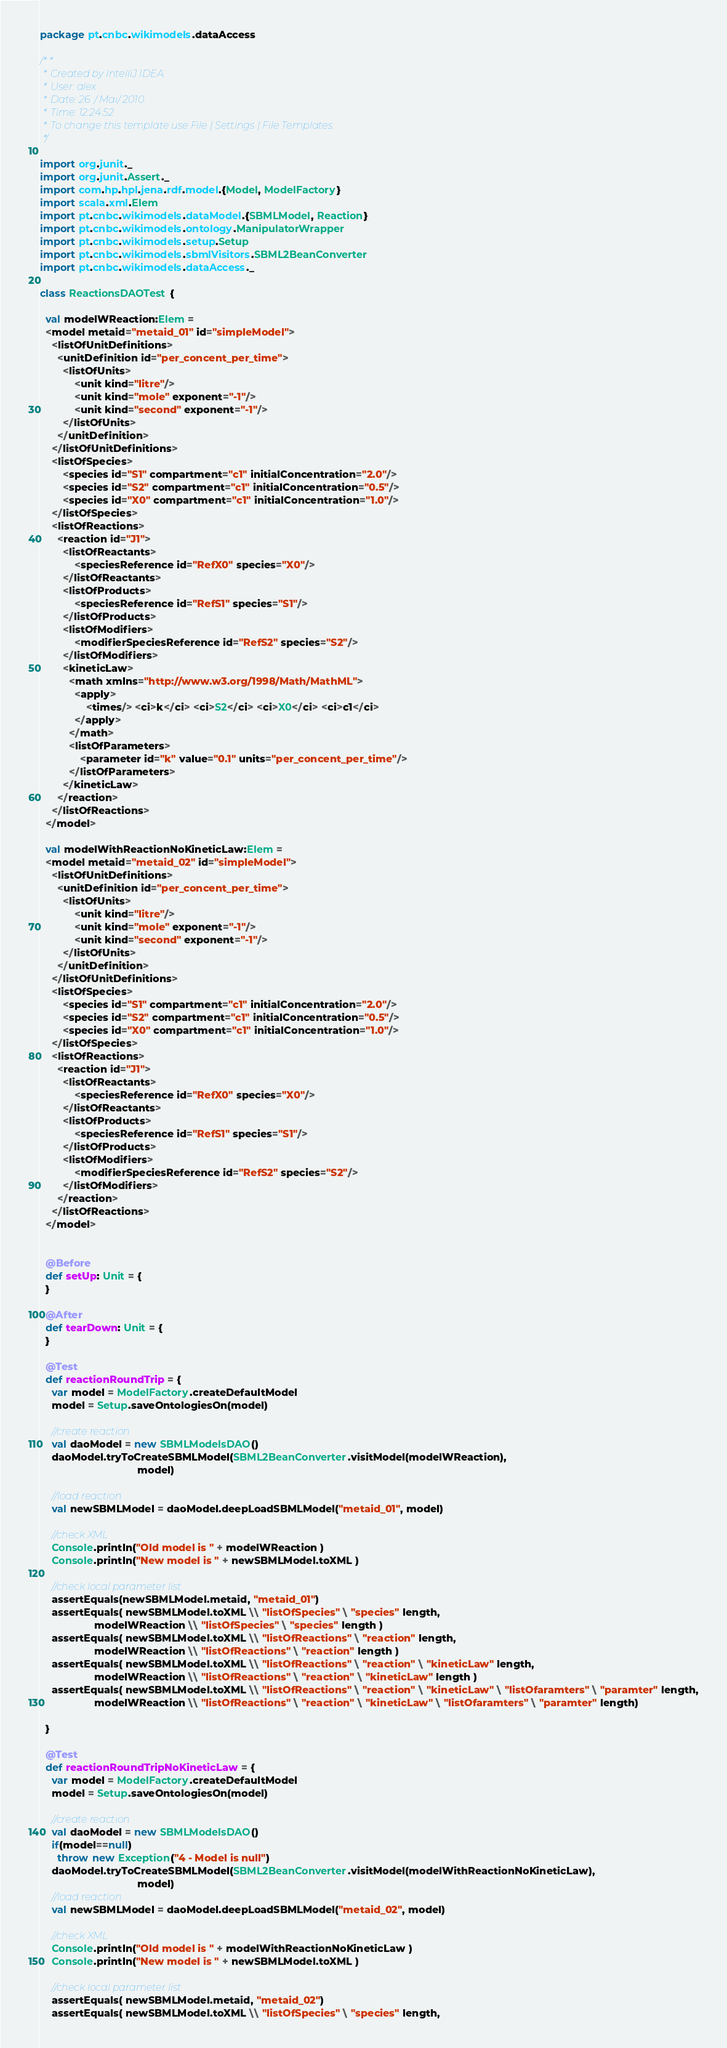Convert code to text. <code><loc_0><loc_0><loc_500><loc_500><_Scala_>package pt.cnbc.wikimodels.dataAccess

/**
 * Created by IntelliJ IDEA.
 * User: alex
 * Date: 26/Mai/2010
 * Time: 12:24:52
 * To change this template use File | Settings | File Templates.
 */

import org.junit._
import org.junit.Assert._
import com.hp.hpl.jena.rdf.model.{Model, ModelFactory}
import scala.xml.Elem
import pt.cnbc.wikimodels.dataModel.{SBMLModel, Reaction}
import pt.cnbc.wikimodels.ontology.ManipulatorWrapper
import pt.cnbc.wikimodels.setup.Setup
import pt.cnbc.wikimodels.sbmlVisitors.SBML2BeanConverter
import pt.cnbc.wikimodels.dataAccess._

class ReactionsDAOTest {

  val modelWReaction:Elem =
  <model metaid="metaid_01" id="simpleModel">
    <listOfUnitDefinitions>
      <unitDefinition id="per_concent_per_time">
        <listOfUnits>
            <unit kind="litre"/>
            <unit kind="mole" exponent="-1"/>
            <unit kind="second" exponent="-1"/>
        </listOfUnits>
      </unitDefinition>
    </listOfUnitDefinitions>
    <listOfSpecies>
        <species id="S1" compartment="c1" initialConcentration="2.0"/>
        <species id="S2" compartment="c1" initialConcentration="0.5"/>
        <species id="X0" compartment="c1" initialConcentration="1.0"/>
    </listOfSpecies>
    <listOfReactions>
      <reaction id="J1">
        <listOfReactants>
            <speciesReference id="RefX0" species="X0"/>
        </listOfReactants>
        <listOfProducts>
            <speciesReference id="RefS1" species="S1"/>
        </listOfProducts>
        <listOfModifiers>
            <modifierSpeciesReference id="RefS2" species="S2"/>
        </listOfModifiers>
        <kineticLaw>
          <math xmlns="http://www.w3.org/1998/Math/MathML">
            <apply>
                <times/> <ci>k</ci> <ci>S2</ci> <ci>X0</ci> <ci>c1</ci>
            </apply>
          </math>
          <listOfParameters>
              <parameter id="k" value="0.1" units="per_concent_per_time"/>
          </listOfParameters>
        </kineticLaw>
      </reaction>
    </listOfReactions>
  </model>

  val modelWithReactionNoKineticLaw:Elem =
  <model metaid="metaid_02" id="simpleModel">
    <listOfUnitDefinitions>
      <unitDefinition id="per_concent_per_time">
        <listOfUnits>
            <unit kind="litre"/>
            <unit kind="mole" exponent="-1"/>
            <unit kind="second" exponent="-1"/>
        </listOfUnits>
      </unitDefinition>
    </listOfUnitDefinitions>
    <listOfSpecies>
        <species id="S1" compartment="c1" initialConcentration="2.0"/>
        <species id="S2" compartment="c1" initialConcentration="0.5"/>
        <species id="X0" compartment="c1" initialConcentration="1.0"/>
    </listOfSpecies>
    <listOfReactions>
      <reaction id="J1">
        <listOfReactants>
            <speciesReference id="RefX0" species="X0"/>
        </listOfReactants>
        <listOfProducts>
            <speciesReference id="RefS1" species="S1"/>
        </listOfProducts>
        <listOfModifiers>
            <modifierSpeciesReference id="RefS2" species="S2"/>
        </listOfModifiers>
      </reaction>
    </listOfReactions>
  </model>


  @Before
  def setUp: Unit = {
  }

  @After
  def tearDown: Unit = {
  }

  @Test
  def reactionRoundTrip = {
    var model = ModelFactory.createDefaultModel
    model = Setup.saveOntologiesOn(model)

    //create reaction
    val daoModel = new SBMLModelsDAO()
    daoModel.tryToCreateSBMLModel(SBML2BeanConverter.visitModel(modelWReaction),
                                  model)

    //load reaction
    val newSBMLModel = daoModel.deepLoadSBMLModel("metaid_01", model)

    //check XML
    Console.println("Old model is " + modelWReaction )
    Console.println("New model is " + newSBMLModel.toXML )

    //check local parameter list
    assertEquals(newSBMLModel.metaid, "metaid_01")
    assertEquals( newSBMLModel.toXML \\ "listOfSpecies" \ "species" length,
                   modelWReaction \\ "listOfSpecies" \ "species" length )
    assertEquals( newSBMLModel.toXML \\ "listOfReactions" \ "reaction" length,
                   modelWReaction \\ "listOfReactions" \ "reaction" length )
    assertEquals( newSBMLModel.toXML \\ "listOfReactions" \ "reaction" \ "kineticLaw" length,
                   modelWReaction \\ "listOfReactions" \ "reaction" \ "kineticLaw" length )
    assertEquals( newSBMLModel.toXML \\ "listOfReactions" \ "reaction" \ "kineticLaw" \ "listOfaramters" \ "paramter" length,
                   modelWReaction \\ "listOfReactions" \ "reaction" \ "kineticLaw" \ "listOfaramters" \ "paramter" length)

  }

  @Test
  def reactionRoundTripNoKineticLaw = {
    var model = ModelFactory.createDefaultModel
    model = Setup.saveOntologiesOn(model)

    //create reaction
    val daoModel = new SBMLModelsDAO()
    if(model==null)
      throw new Exception("4 - Model is null")
    daoModel.tryToCreateSBMLModel(SBML2BeanConverter.visitModel(modelWithReactionNoKineticLaw),
                                  model)
    //load reaction
    val newSBMLModel = daoModel.deepLoadSBMLModel("metaid_02", model)

    //check XML
    Console.println("Old model is " + modelWithReactionNoKineticLaw )
    Console.println("New model is " + newSBMLModel.toXML )

    //check local parameter list
    assertEquals( newSBMLModel.metaid, "metaid_02")
    assertEquals( newSBMLModel.toXML \\ "listOfSpecies" \ "species" length,</code> 